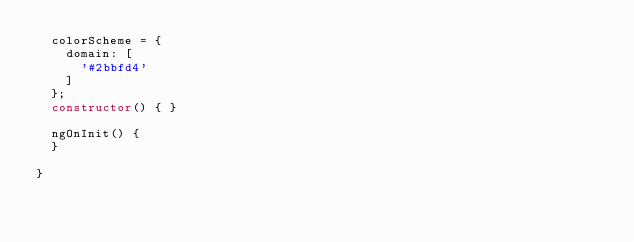<code> <loc_0><loc_0><loc_500><loc_500><_TypeScript_>  colorScheme = {
    domain: [
      '#2bbfd4'
    ]
  };
  constructor() { }

  ngOnInit() {
  }

}
</code> 